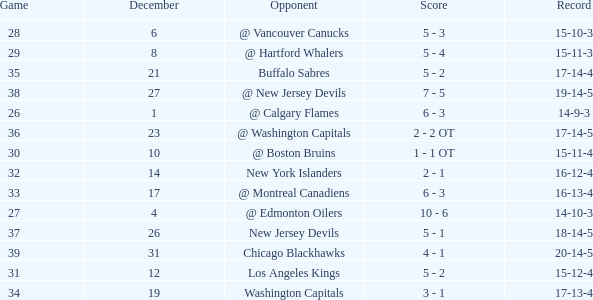Game larger than 34, and a December smaller than 23 had what record? 17-14-4. 